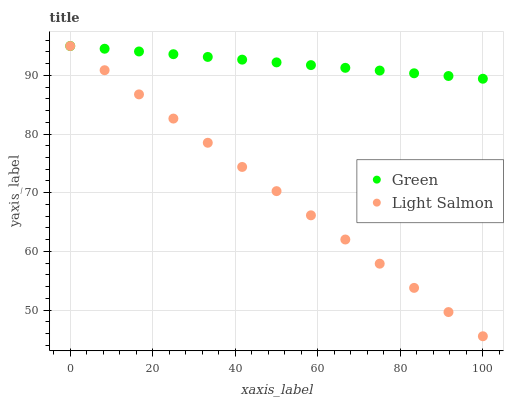Does Light Salmon have the minimum area under the curve?
Answer yes or no. Yes. Does Green have the maximum area under the curve?
Answer yes or no. Yes. Does Green have the minimum area under the curve?
Answer yes or no. No. Is Light Salmon the smoothest?
Answer yes or no. Yes. Is Green the roughest?
Answer yes or no. Yes. Is Green the smoothest?
Answer yes or no. No. Does Light Salmon have the lowest value?
Answer yes or no. Yes. Does Green have the lowest value?
Answer yes or no. No. Does Green have the highest value?
Answer yes or no. Yes. Does Light Salmon intersect Green?
Answer yes or no. Yes. Is Light Salmon less than Green?
Answer yes or no. No. Is Light Salmon greater than Green?
Answer yes or no. No. 